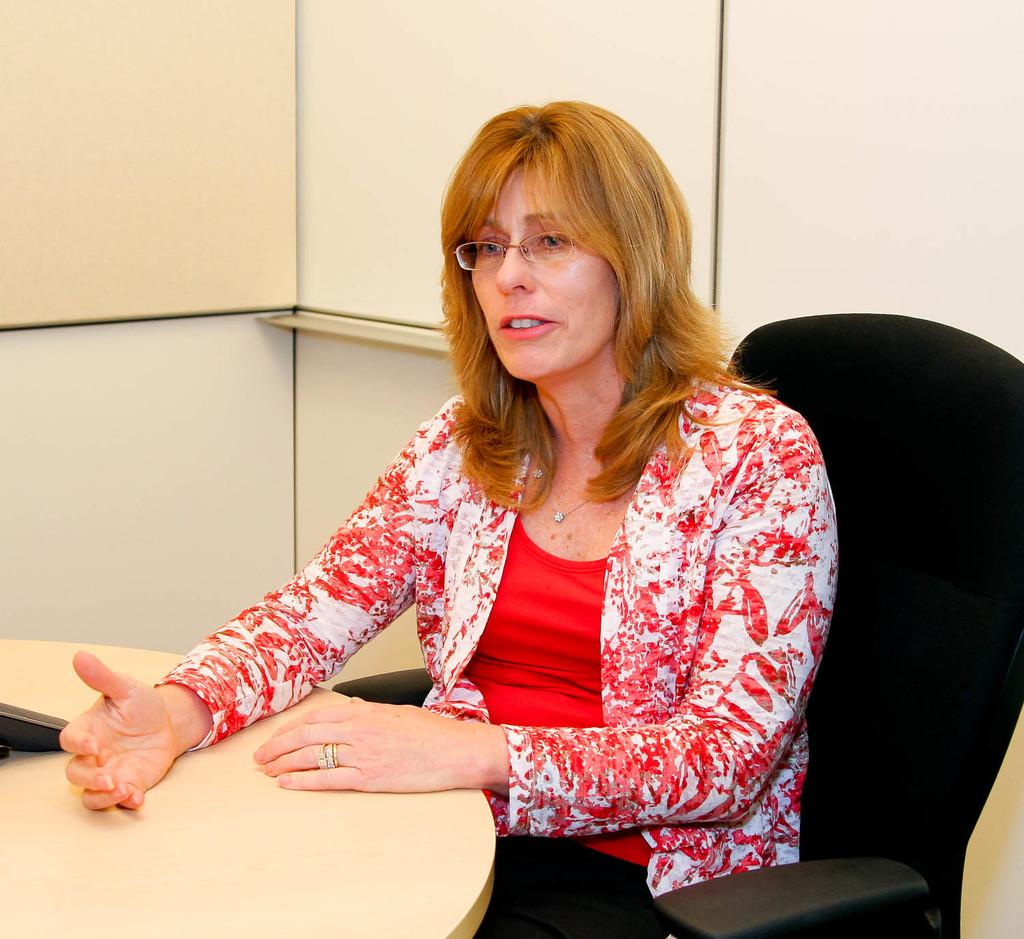What is the person in the image doing? The person is sitting on a chair in the image. What can be seen on the table in the image? There is an object on a table in the image. What is visible in the background of the image? There is a wall in the background of the image. How many goldfish are swimming in the person's heart in the image? There are no goldfish present in the image, and the person's heart is not visible. 